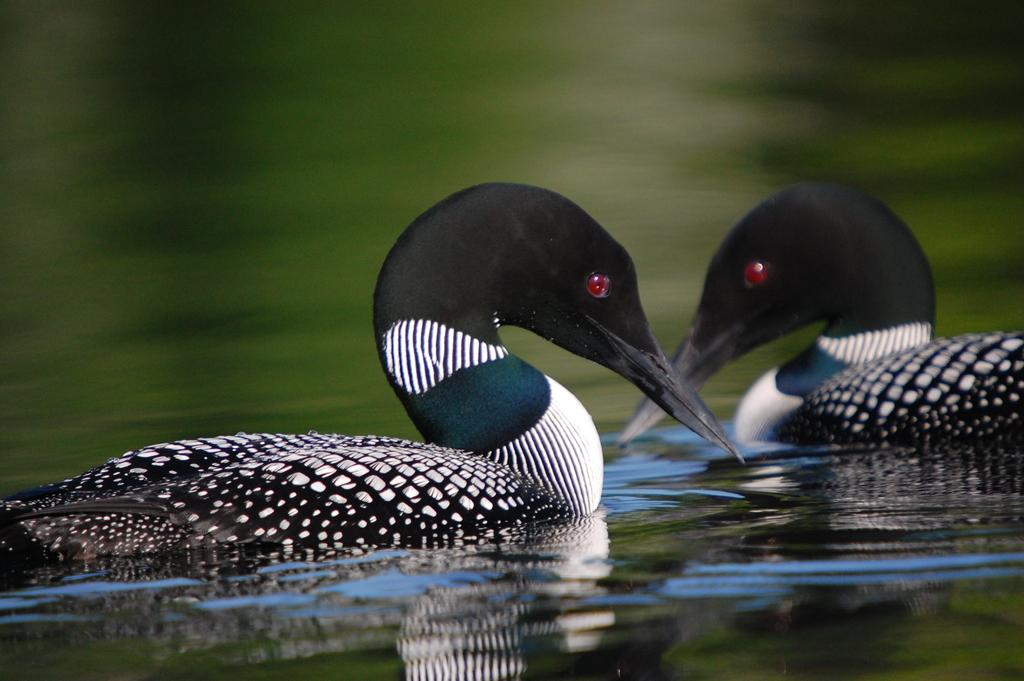What animals are present in the image? There are two ducks in the image. Where are the ducks located? The ducks are in the water. How many cobwebs can be seen in the image? There are no cobwebs present in the image. What year is depicted in the image? The image does not depict a specific year; it only shows two ducks in the water. 